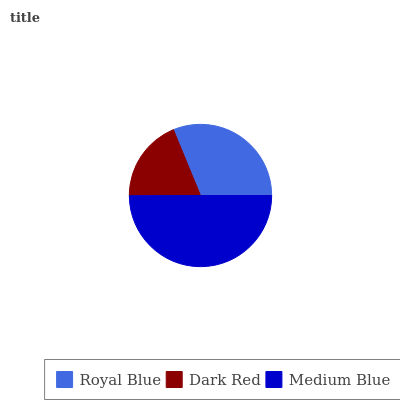Is Dark Red the minimum?
Answer yes or no. Yes. Is Medium Blue the maximum?
Answer yes or no. Yes. Is Medium Blue the minimum?
Answer yes or no. No. Is Dark Red the maximum?
Answer yes or no. No. Is Medium Blue greater than Dark Red?
Answer yes or no. Yes. Is Dark Red less than Medium Blue?
Answer yes or no. Yes. Is Dark Red greater than Medium Blue?
Answer yes or no. No. Is Medium Blue less than Dark Red?
Answer yes or no. No. Is Royal Blue the high median?
Answer yes or no. Yes. Is Royal Blue the low median?
Answer yes or no. Yes. Is Medium Blue the high median?
Answer yes or no. No. Is Medium Blue the low median?
Answer yes or no. No. 